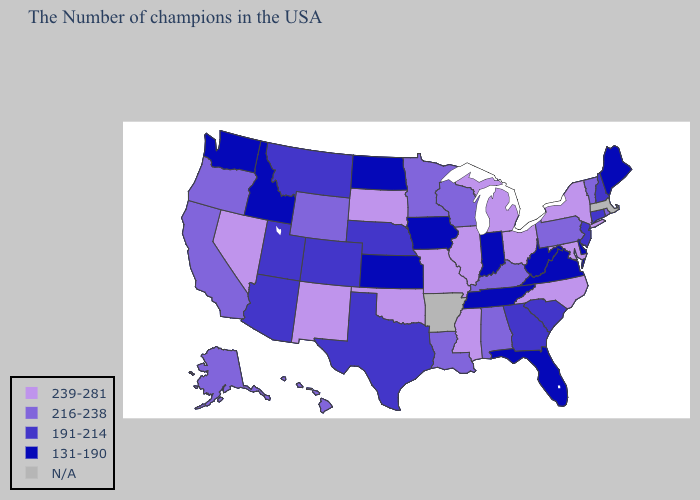Among the states that border Rhode Island , which have the highest value?
Short answer required. Connecticut. Does Louisiana have the highest value in the South?
Give a very brief answer. No. Which states have the lowest value in the South?
Keep it brief. Delaware, Virginia, West Virginia, Florida, Tennessee. Does the map have missing data?
Write a very short answer. Yes. What is the highest value in the MidWest ?
Quick response, please. 239-281. Name the states that have a value in the range 216-238?
Quick response, please. Rhode Island, Vermont, Pennsylvania, Kentucky, Alabama, Wisconsin, Louisiana, Minnesota, Wyoming, California, Oregon, Alaska, Hawaii. What is the highest value in the Northeast ?
Write a very short answer. 239-281. What is the lowest value in the USA?
Concise answer only. 131-190. How many symbols are there in the legend?
Concise answer only. 5. What is the lowest value in states that border Washington?
Answer briefly. 131-190. Does North Carolina have the highest value in the South?
Keep it brief. Yes. Which states hav the highest value in the Northeast?
Short answer required. New York. What is the lowest value in states that border New Hampshire?
Concise answer only. 131-190. Among the states that border Mississippi , which have the lowest value?
Be succinct. Tennessee. What is the value of Minnesota?
Quick response, please. 216-238. 